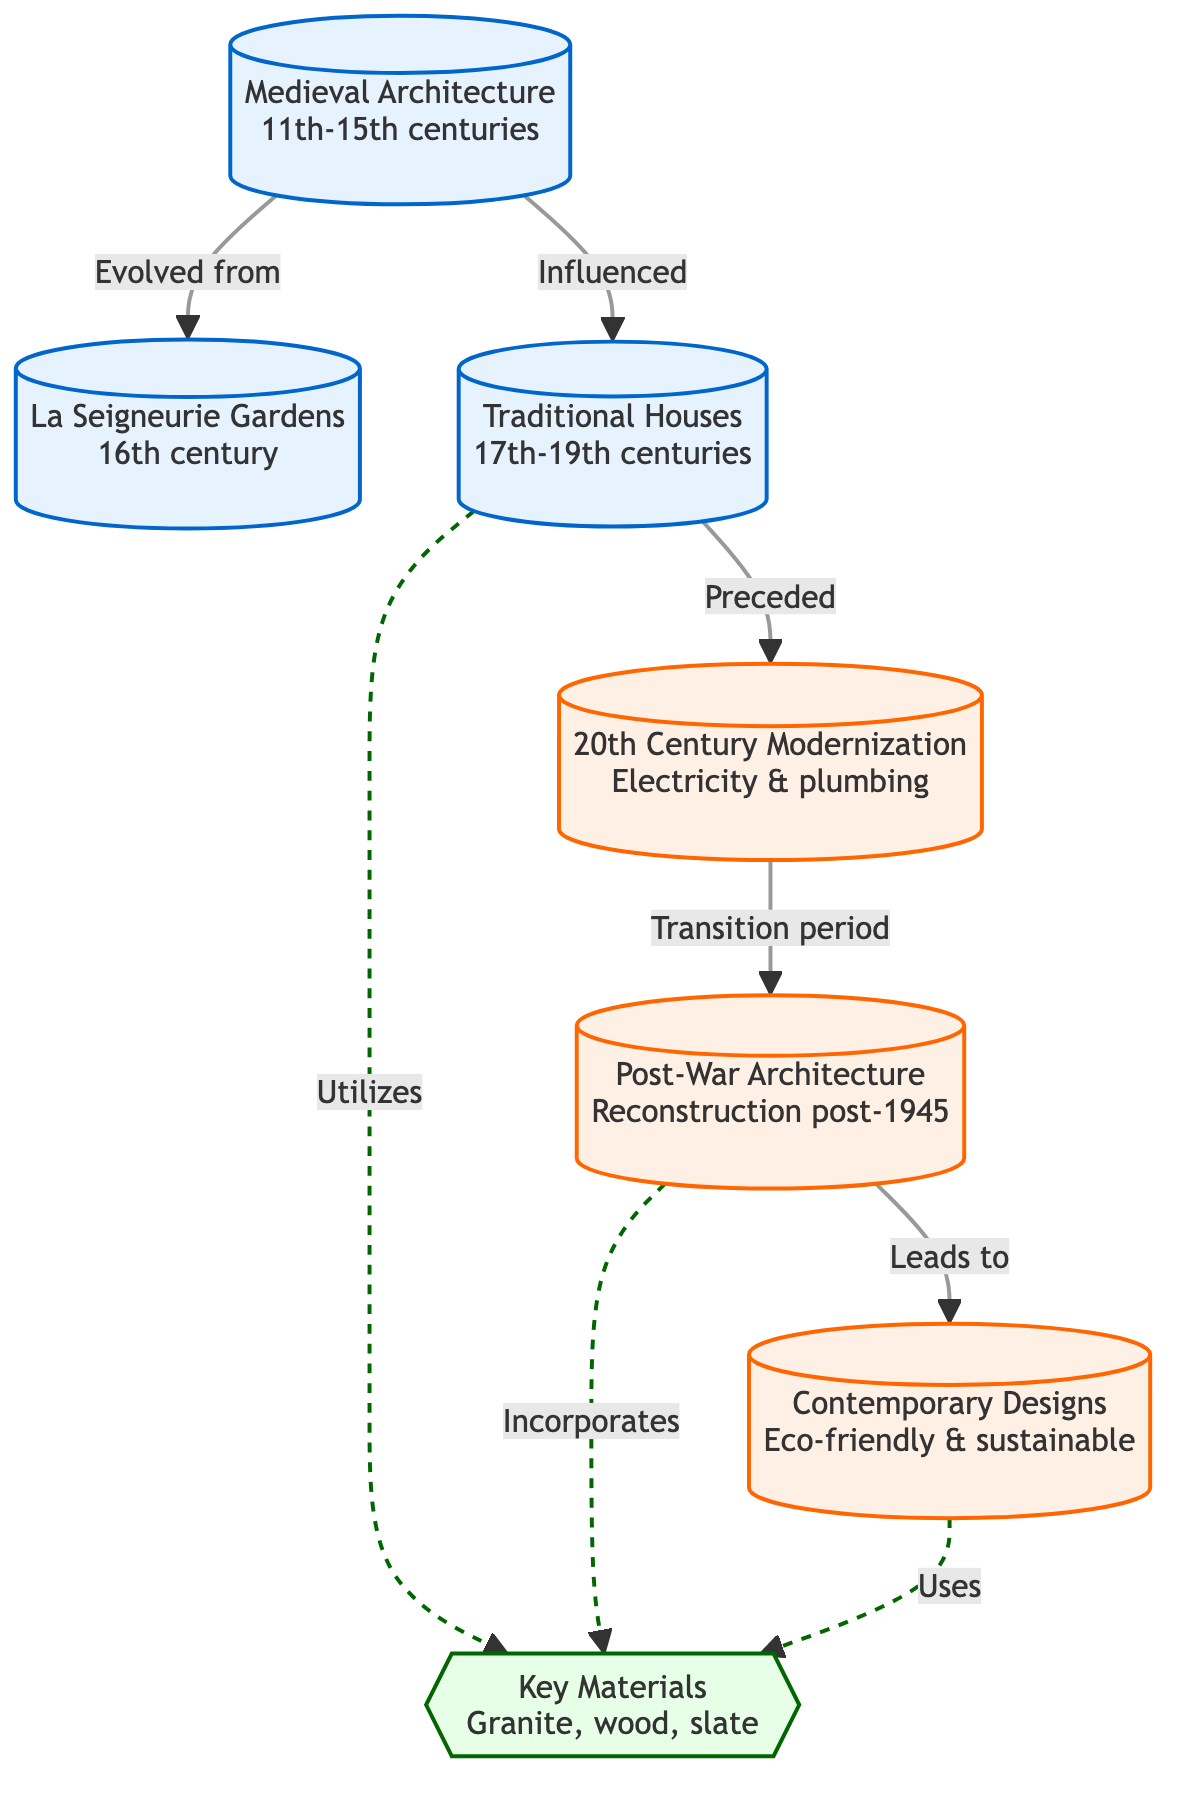What period does Medieval Architecture cover? The diagram indicates that Medieval Architecture spans the 11th to 15th centuries, as denoted in the node labeled "Medieval Architecture."
Answer: 11th-15th centuries Which architectural style evolved from Medieval Architecture? According to the diagram, La Seigneurie Gardens is stated to have evolved from Medieval Architecture, as shown by the arrow labeled "Evolved from."
Answer: La Seigneurie Gardens What material is mentioned as being utilized by Traditional Houses? The diagram shows that Traditional Houses "Utilizes" key materials, specifically granite, wood, and slate, as indicated by the dashed line.
Answer: Granite, wood, slate How many modern architectural styles are shown in the diagram? The diagram lists three modern styles: 20th Century Modernization, Post-War Architecture, and Contemporary Designs. By counting the nodes labeled as modern, one can confirm this.
Answer: 3 What is the flow relationship between Post-War Architecture and Contemporary Designs? The diagram indicates a direct relationship where Post-War Architecture "Leads to" Contemporary Designs, as shown by the directional arrow connecting the two nodes.
Answer: Leads to Which two nodes are related to key materials? The diagram reveals that both Traditional Houses and Post-War Architecture "Incorporates" key materials, indicated by the dashed lines connecting these nodes to the "Key Materials" node.
Answer: Traditional Houses, Post-War Architecture What transition does the diagram illustrate between 20th Century Modernization and Post-War Architecture? The diagram explicitly states that there is a "Transition period" between 20th Century Modernization and Post-War Architecture, depicted by the arrow connecting these two styles.
Answer: Transition period What does the dashed line signify in the diagram? The dashed lines in the diagram indicate a relationship involving the incorporation of key materials, rather than a direct evolutionary connection, as seen from the context of the nodes it connects.
Answer: Incorporation of materials Which architectural style is shown as preceding 20th Century Modernization? The diagram indicates that Traditional Houses "Preceded" 20th Century Modernization, as denoted by the arrow connecting these two style nodes.
Answer: Traditional Houses 